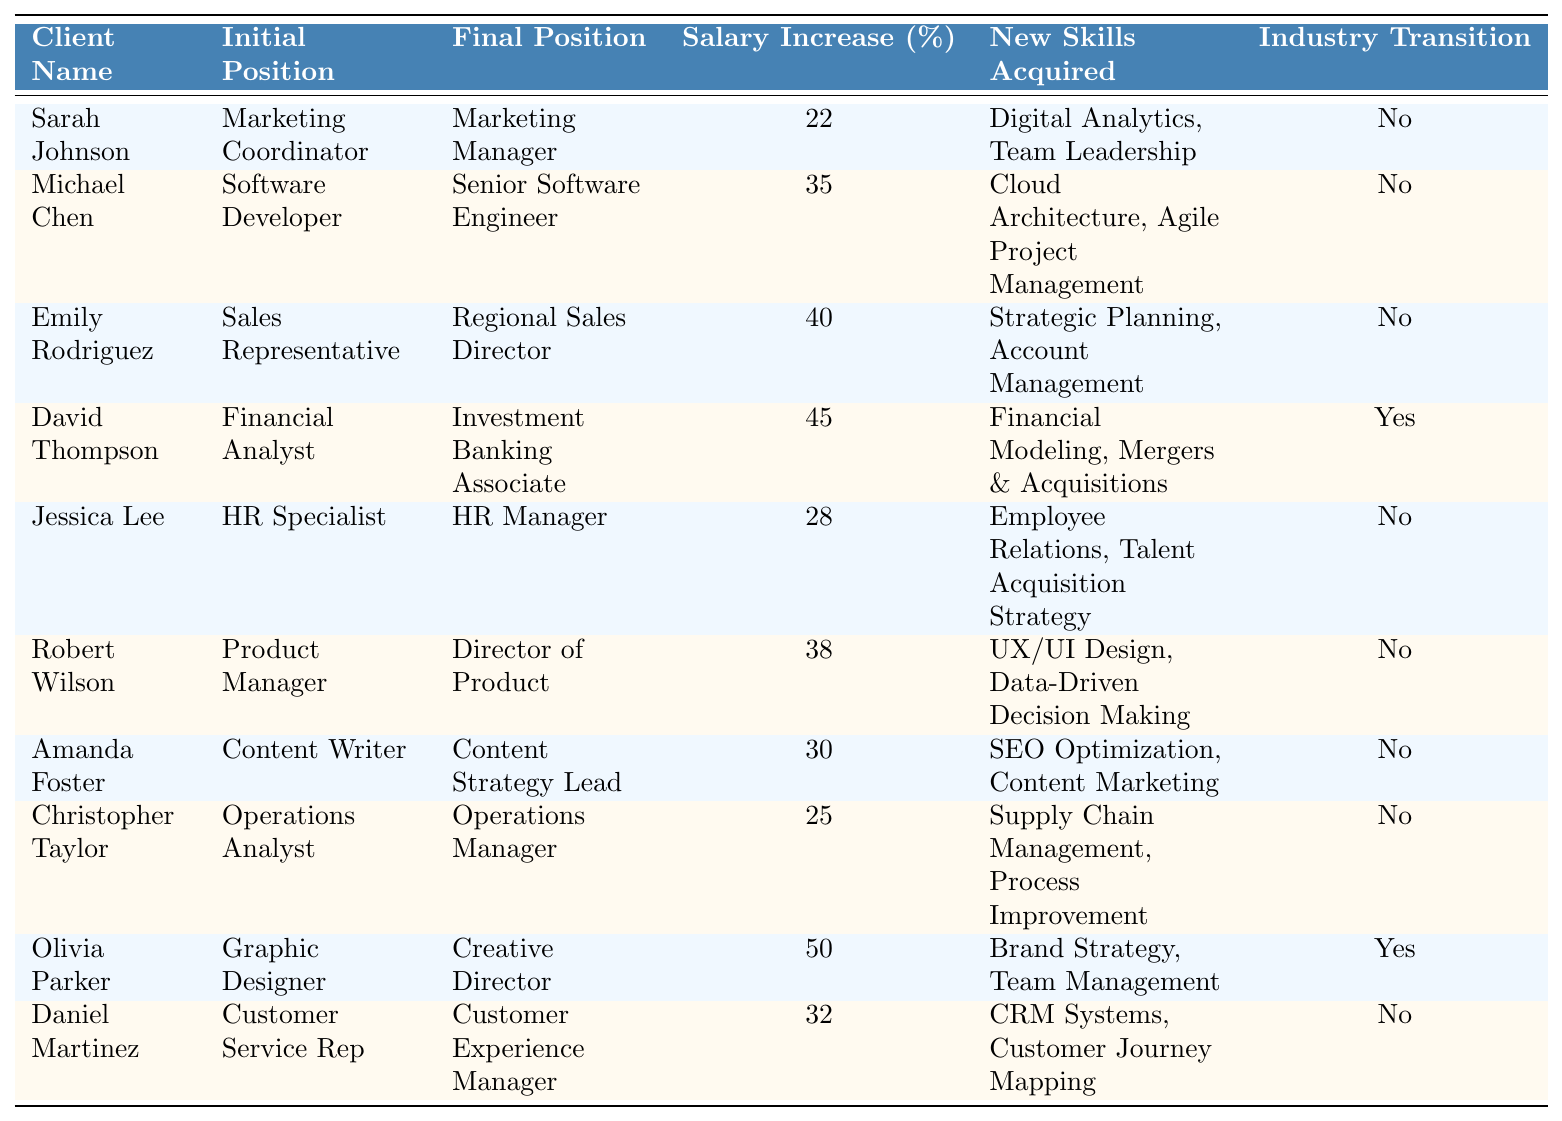What is the highest salary increase percentage achieved by a client? The table shows the salary increases for each client. The highest value is 50%, achieved by Olivia Parker.
Answer: 50% How many clients transitioned into a different industry? The table indicates whether a client made an industry transition. By checking the "Industry Transition" column, David Thompson and Olivia Parker both transitioned, totaling 2 clients.
Answer: 2 Who acquired the most new skills? We look at the "New Skills Acquired" column and count the skills for each client. David Thompson and Olivia Parker have 2 skills, while others have 1 or none. Therefore, David Thompson and Olivia Parker are tied for acquiring the most new skills.
Answer: David Thompson and Olivia Parker Which client had the lowest salary increase? By examining the "Salary Increase (%)" column, Christopher Taylor's increase is the lowest at 25%.
Answer: 25% What is the average salary increase percentage for all clients? To calculate the average, we sum the salary increases (22 + 35 + 40 + 45 + 28 + 38 + 30 + 25 + 50 + 32) = 345, then divide by the number of clients (10), resulting in 34.5%.
Answer: 34.5% How many clients moved to managerial roles? We check the "Final Position" column for roles that include "Manager" in their title. The roles are: Marketing Manager, Senior Software Engineer, Regional Sales Director, HR Manager, Director of Product, Content Strategy Lead, Operations Manager, and Customer Experience Manager—all indicating 8 clients moved to managerial roles.
Answer: 8 Did any client achieve a salary increase of more than 40% while also transitioning industries? Checking both the "Salary Increase (%)" and "Industry Transition" columns, only David Thompson achieved a salary increase of 45% and transitioned industries; therefore, yes, it's true he meets both conditions.
Answer: Yes What is the difference in salary increase percentage between the highest and lowest increases? The highest increase is 50% (Olivia Parker) and the lowest is 25% (Christopher Taylor). The difference is calculated as 50 - 25 = 25%.
Answer: 25% Which clients did not acquire any new skills? We check the "New Skills Acquired" column for clients with "No" and find Sarah Johnson, Michael Chen, Emily Rodriguez, Jessica Lee, Robert Wilson, Amanda Foster, Christopher Taylor, and Daniel Martinez. This totals 8 clients who did not acquire new skills.
Answer: 8 